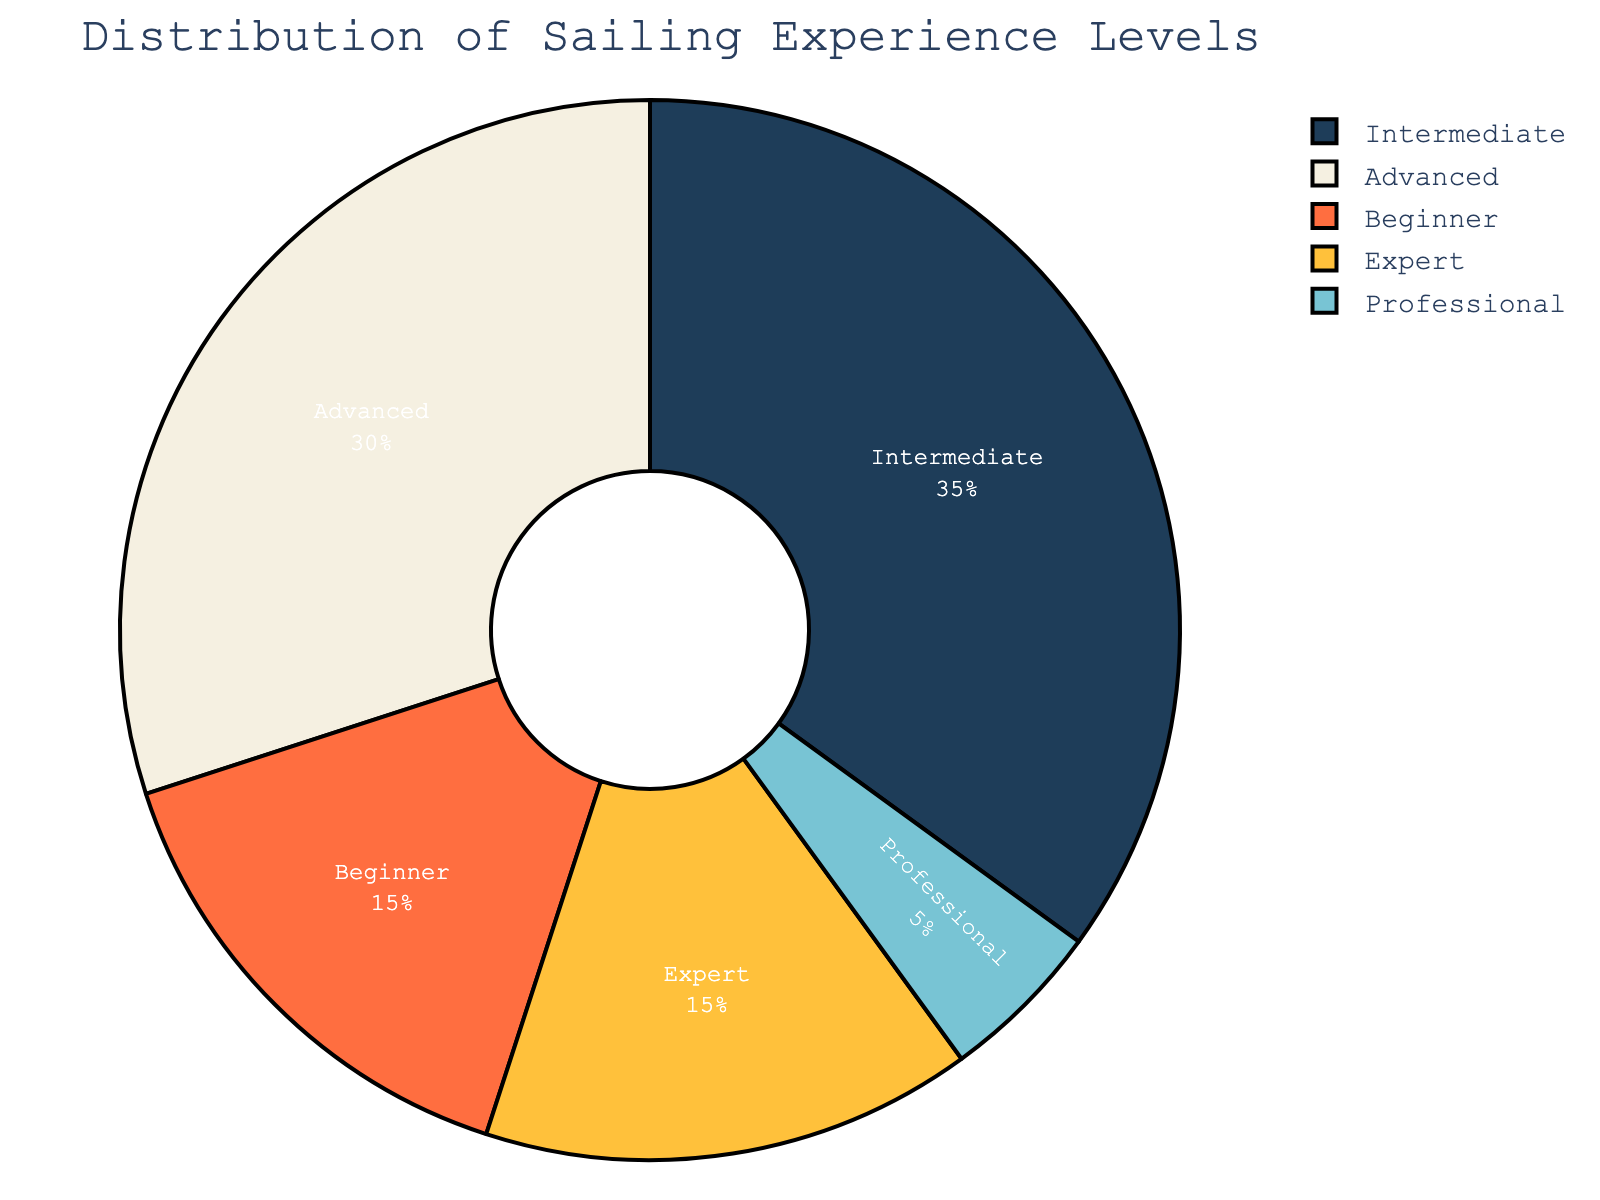What percentage of club members are classified as experts? The pie chart shows a segment labeled "Expert" which represents a percentage of the whole. According to the data provided, this percentage is visibly denoted on the chart.
Answer: 15% Is the proportion of professionals greater than the proportion of beginners? By examining the segments labeled "Professional" and "Beginner," we can compare their sizes. The "Professional" segment is much smaller than the "Beginner" segment. According to the data, beginners hold 15% while professionals hold 5%.
Answer: No What is the combined percentage of advanced and expert sailors in the club? Look for the segments labeled "Advanced" and "Expert" and add their percentages: Advanced (30%) + Expert (15%) = 45%.
Answer: 45% How does the size of the intermediate segment compare to the advanced segment? The pie chart segments labeled "Intermediate" and "Advanced" show differing sizes. The intermediate segment is slightly larger than the advanced segment. According to the data, Intermediate is 35% and Advanced is 30%.
Answer: Intermediate is larger Which experience level holds the smallest percentage, and what is it? Identify the smallest segment in the pie chart by visually comparing all segments. The data shows that "Professional" is the smallest with 5%.
Answer: Professional, 5% If you sum up the percentages of intermediate and beginner members, is it more or less than the combined percentage of advanced and expert members? Add the percentages for both sets of experience levels: Intermediate (35%) + Beginner (15%) = 50%, and Advanced (30%) + Expert (15%) = 45%. Since 50% is greater than 45%, the former sum is larger.
Answer: More In terms of size, which segment is third largest and what is its percentage? Visually rank the segments by size from largest to smallest. The third largest segment is likely "Advanced," after "Intermediate" and "Beginner." According to the data, "Advanced" is 30%.
Answer: Advanced, 30% What is the ratio of beginners to professionals in the club? Use the percentages for beginners (15%) and professionals (5%) to determine the ratio: 15% ÷ 5% = 3, so the ratio is 3:1.
Answer: 3:1 